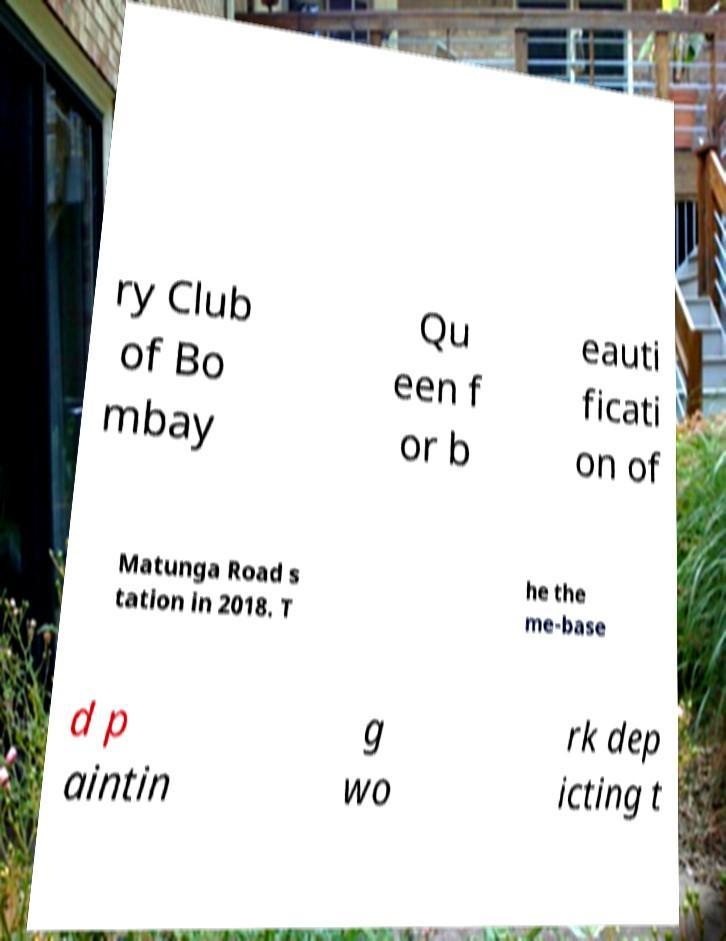What messages or text are displayed in this image? I need them in a readable, typed format. ry Club of Bo mbay Qu een f or b eauti ficati on of Matunga Road s tation in 2018. T he the me-base d p aintin g wo rk dep icting t 